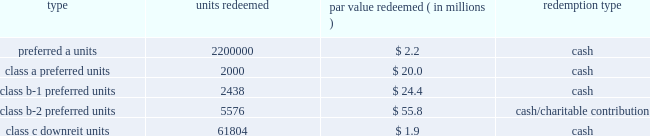Kimco realty corporation and subsidiaries notes to consolidated financial statements , continued the units consisted of ( i ) approximately 81.8 million preferred a units par value $ 1.00 per unit , which pay the holder a return of 7.0% ( 7.0 % ) per annum on the preferred a par value and are redeemable for cash by the holder at any time after one year or callable by the company any time after six months and contain a promote feature based upon an increase in net operating income of the properties capped at a 10.0% ( 10.0 % ) increase , ( ii ) 2000 class a preferred units , par value $ 10000 per unit , which pay the holder a return equal to libor plus 2.0% ( 2.0 % ) per annum on the class a preferred par value and are redeemable for cash by the holder at any time after november 30 , 2010 , ( iii ) 2627 class b-1 preferred units , par value $ 10000 per unit , which pay the holder a return equal to 7.0% ( 7.0 % ) per annum on the class b-1 preferred par value and are redeemable by the holder at any time after november 30 , 2010 , for cash or at the company 2019s option , shares of the company 2019s common stock , equal to the cash redemption amount , as defined , ( iv ) 5673 class b-2 preferred units , par value $ 10000 per unit , which pay the holder a return equal to 7.0% ( 7.0 % ) per annum on the class b-2 preferred par value and are redeemable for cash by the holder at any time after november 30 , 2010 , and ( v ) 640001 class c downreit units , valued at an issuance price of $ 30.52 per unit which pay the holder a return at a rate equal to the company 2019s common stock dividend and are redeemable by the holder at any time after november 30 , 2010 , for cash or at the company 2019s option , shares of the company 2019s common stock equal to the class c cash amount , as defined .
The following units have been redeemed as of december 31 , 2010 : redeemed par value redeemed ( in millions ) redemption type .
Noncontrolling interest relating to the remaining units was $ 110.4 million and $ 113.1 million as of december 31 , 2010 and 2009 , respectively .
During 2006 , the company acquired two shopping center properties located in bay shore and centereach , ny .
Included in noncontrolling interests was approximately $ 41.6 million , including a discount of $ 0.3 million and a fair market value adjustment of $ 3.8 million , in redeemable units ( the 201credeemable units 201d ) , issued by the company in connection with these transactions .
The prop- erties were acquired through the issuance of $ 24.2 million of redeemable units , which are redeemable at the option of the holder ; approximately $ 14.0 million of fixed rate redeemable units and the assumption of approximately $ 23.4 million of non-recourse debt .
The redeemable units consist of ( i ) 13963 class a units , par value $ 1000 per unit , which pay the holder a return of 5% ( 5 % ) per annum of the class a par value and are redeemable for cash by the holder at any time after april 3 , 2011 , or callable by the company any time after april 3 , 2016 , and ( ii ) 647758 class b units , valued at an issuance price of $ 37.24 per unit , which pay the holder a return at a rate equal to the company 2019s common stock dividend and are redeemable by the holder at any time after april 3 , 2007 , for cash or at the option of the company for common stock at a ratio of 1:1 , or callable by the company any time after april 3 , 2026 .
The company is restricted from disposing of these assets , other than through a tax free transaction , until april 2016 and april 2026 for the centereach , ny , and bay shore , ny , assets , respectively .
During 2007 , 30000 units , or $ 1.1 million par value , of theclass bunits were redeemed by the holder in cash at the option of the company .
Noncontrolling interest relating to the units was $ 40.4 million and $ 40.3 million as of december 31 , 2010 and 2009 , respectively .
Noncontrolling interests also includes 138015 convertible units issued during 2006 , by the company , which were valued at approxi- mately $ 5.3 million , including a fair market value adjustment of $ 0.3 million , related to an interest acquired in an office building located in albany , ny .
These units are redeemable at the option of the holder after one year for cash or at the option of the company for the company 2019s common stock at a ratio of 1:1 .
The holder is entitled to a distribution equal to the dividend rate of the company 2019s common stock .
The company is restricted from disposing of these assets , other than through a tax free transaction , until january 2017. .
What is the average , in millions , of noncontrolling interest relating to the remaining units in 2009-2010? 
Computations: ((110.4 + 113.1) / 2)
Answer: 111.75. 